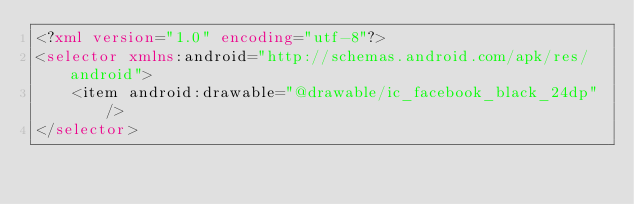<code> <loc_0><loc_0><loc_500><loc_500><_XML_><?xml version="1.0" encoding="utf-8"?>
<selector xmlns:android="http://schemas.android.com/apk/res/android">
    <item android:drawable="@drawable/ic_facebook_black_24dp"/>
</selector></code> 